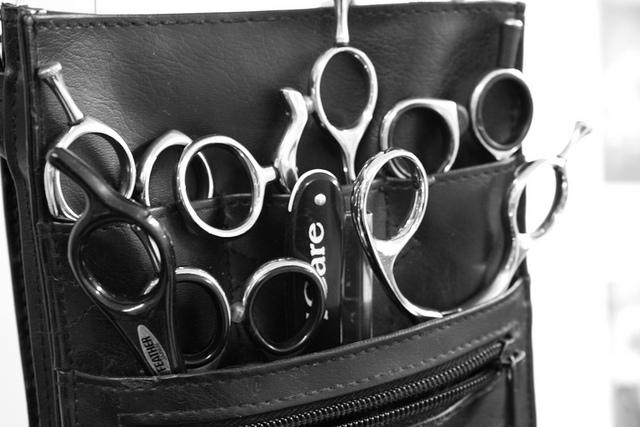What animal might the black item have come from?

Choices:
A) rabbit
B) fish
C) goat
D) cow cow 